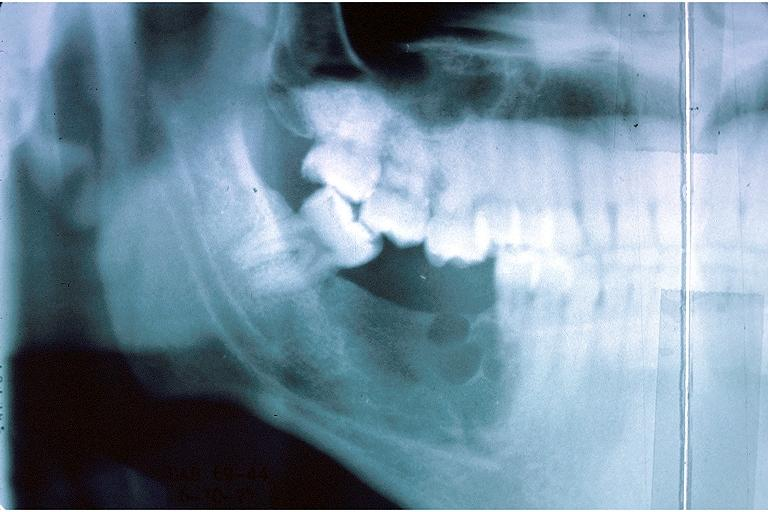s oral present?
Answer the question using a single word or phrase. Yes 